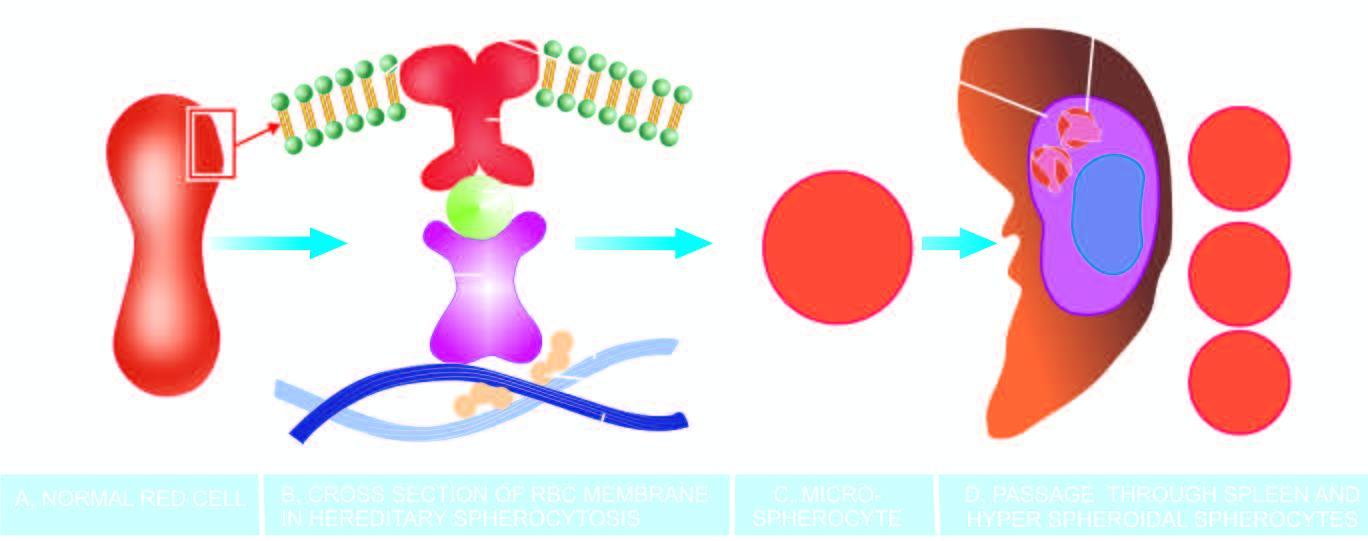when do these rigid spherical cells lose their cell membrane further?
Answer the question using a single word or phrase. During passage through the spleen 